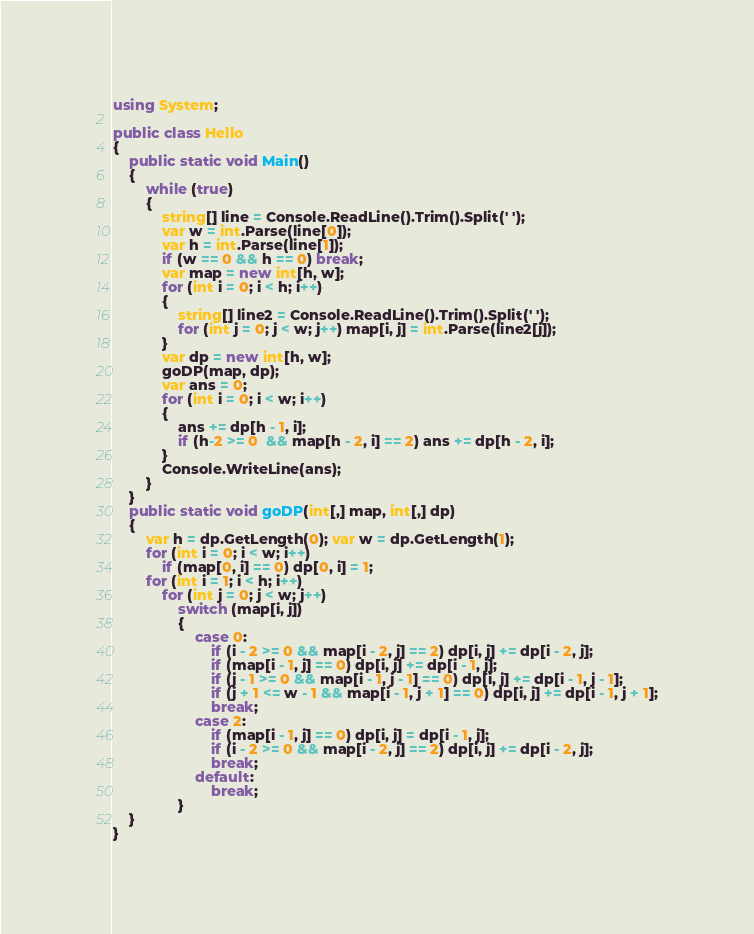<code> <loc_0><loc_0><loc_500><loc_500><_C#_>using System;

public class Hello
{
    public static void Main()
    {
        while (true)
        {
            string[] line = Console.ReadLine().Trim().Split(' ');
            var w = int.Parse(line[0]);
            var h = int.Parse(line[1]);
            if (w == 0 && h == 0) break;
            var map = new int[h, w];
            for (int i = 0; i < h; i++)
            {
                string[] line2 = Console.ReadLine().Trim().Split(' ');
                for (int j = 0; j < w; j++) map[i, j] = int.Parse(line2[j]);
            }
            var dp = new int[h, w];
            goDP(map, dp);
            var ans = 0;
            for (int i = 0; i < w; i++)
            {
                ans += dp[h - 1, i];
                if (h-2 >= 0  && map[h - 2, i] == 2) ans += dp[h - 2, i];
            }
            Console.WriteLine(ans);
        }
    }
    public static void goDP(int[,] map, int[,] dp)
    {
        var h = dp.GetLength(0); var w = dp.GetLength(1);
        for (int i = 0; i < w; i++)
            if (map[0, i] == 0) dp[0, i] = 1;
        for (int i = 1; i < h; i++)
            for (int j = 0; j < w; j++)
                switch (map[i, j])
                {
                    case 0:
                        if (i - 2 >= 0 && map[i - 2, j] == 2) dp[i, j] += dp[i - 2, j];
                        if (map[i - 1, j] == 0) dp[i, j] += dp[i - 1, j];
                        if (j - 1 >= 0 && map[i - 1, j - 1] == 0) dp[i, j] += dp[i - 1, j - 1];
                        if (j + 1 <= w - 1 && map[i - 1, j + 1] == 0) dp[i, j] += dp[i - 1, j + 1];
                        break;
                    case 2:
                        if (map[i - 1, j] == 0) dp[i, j] = dp[i - 1, j];
                        if (i - 2 >= 0 && map[i - 2, j] == 2) dp[i, j] += dp[i - 2, j];
                        break;
                    default:
                        break;
                }
    }
}</code> 